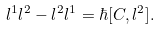<formula> <loc_0><loc_0><loc_500><loc_500>l ^ { 1 } l ^ { 2 } - l ^ { 2 } l ^ { 1 } = \hbar { [ } C , l ^ { 2 } ] .</formula> 